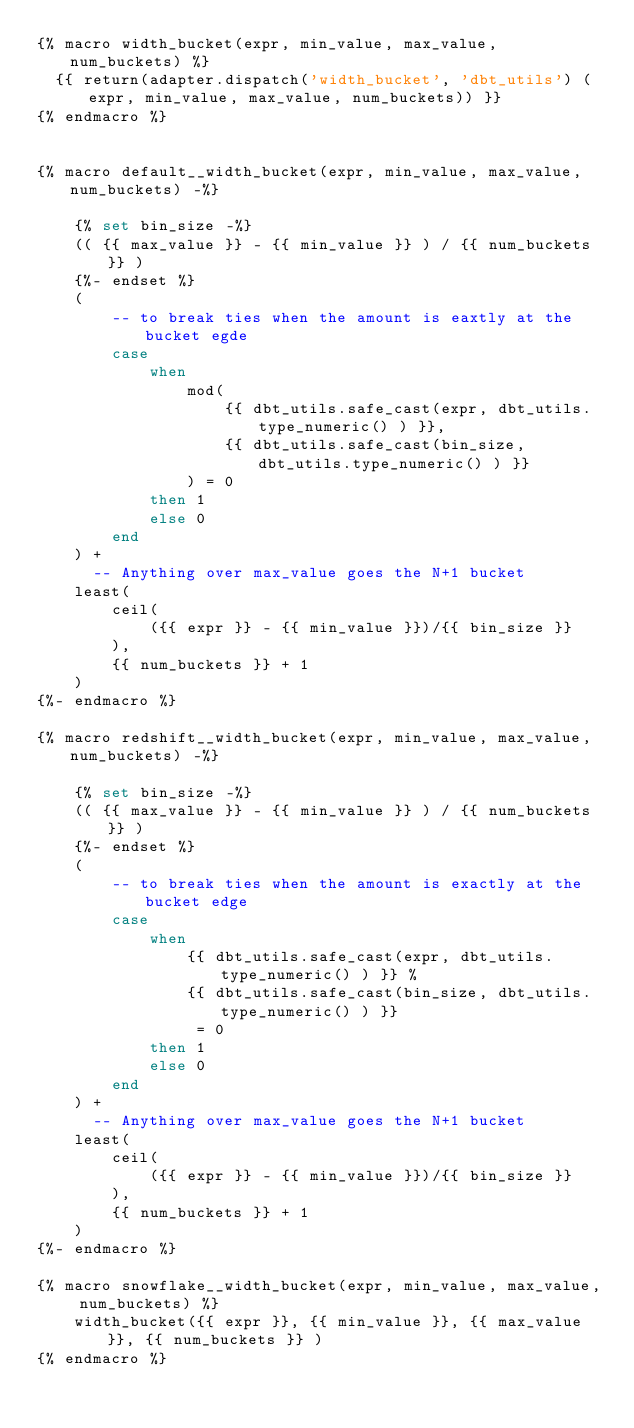<code> <loc_0><loc_0><loc_500><loc_500><_SQL_>{% macro width_bucket(expr, min_value, max_value, num_buckets) %}
  {{ return(adapter.dispatch('width_bucket', 'dbt_utils') (expr, min_value, max_value, num_buckets)) }}
{% endmacro %}


{% macro default__width_bucket(expr, min_value, max_value, num_buckets) -%}

    {% set bin_size -%}
    (( {{ max_value }} - {{ min_value }} ) / {{ num_buckets }} )
    {%- endset %}
    (
        -- to break ties when the amount is eaxtly at the bucket egde
        case
            when
                mod(
                    {{ dbt_utils.safe_cast(expr, dbt_utils.type_numeric() ) }},
                    {{ dbt_utils.safe_cast(bin_size, dbt_utils.type_numeric() ) }}
                ) = 0
            then 1
            else 0
        end
    ) +
      -- Anything over max_value goes the N+1 bucket
    least(
        ceil(
            ({{ expr }} - {{ min_value }})/{{ bin_size }}
        ),
        {{ num_buckets }} + 1
    )
{%- endmacro %}

{% macro redshift__width_bucket(expr, min_value, max_value, num_buckets) -%}

    {% set bin_size -%}
    (( {{ max_value }} - {{ min_value }} ) / {{ num_buckets }} )
    {%- endset %}
    (
        -- to break ties when the amount is exactly at the bucket edge
        case
            when
                {{ dbt_utils.safe_cast(expr, dbt_utils.type_numeric() ) }} %
                {{ dbt_utils.safe_cast(bin_size, dbt_utils.type_numeric() ) }}
                 = 0
            then 1
            else 0
        end
    ) +
      -- Anything over max_value goes the N+1 bucket
    least(
        ceil(
            ({{ expr }} - {{ min_value }})/{{ bin_size }}
        ),
        {{ num_buckets }} + 1
    )
{%- endmacro %}

{% macro snowflake__width_bucket(expr, min_value, max_value, num_buckets) %}
    width_bucket({{ expr }}, {{ min_value }}, {{ max_value }}, {{ num_buckets }} )
{% endmacro %}
</code> 